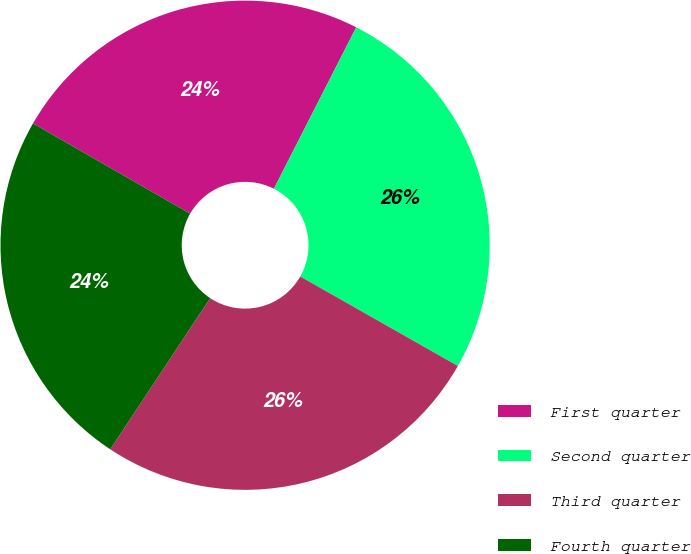<chart> <loc_0><loc_0><loc_500><loc_500><pie_chart><fcel>First quarter<fcel>Second quarter<fcel>Third quarter<fcel>Fourth quarter<nl><fcel>24.21%<fcel>25.71%<fcel>26.08%<fcel>24.0%<nl></chart> 